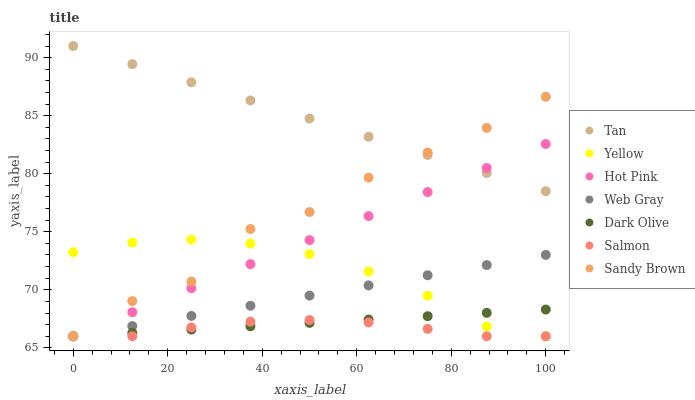Does Salmon have the minimum area under the curve?
Answer yes or no. Yes. Does Tan have the maximum area under the curve?
Answer yes or no. Yes. Does Dark Olive have the minimum area under the curve?
Answer yes or no. No. Does Dark Olive have the maximum area under the curve?
Answer yes or no. No. Is Web Gray the smoothest?
Answer yes or no. Yes. Is Sandy Brown the roughest?
Answer yes or no. Yes. Is Dark Olive the smoothest?
Answer yes or no. No. Is Dark Olive the roughest?
Answer yes or no. No. Does Hot Pink have the lowest value?
Answer yes or no. Yes. Does Tan have the lowest value?
Answer yes or no. No. Does Tan have the highest value?
Answer yes or no. Yes. Does Dark Olive have the highest value?
Answer yes or no. No. Is Salmon less than Tan?
Answer yes or no. Yes. Is Tan greater than Web Gray?
Answer yes or no. Yes. Does Yellow intersect Web Gray?
Answer yes or no. Yes. Is Yellow less than Web Gray?
Answer yes or no. No. Is Yellow greater than Web Gray?
Answer yes or no. No. Does Salmon intersect Tan?
Answer yes or no. No. 